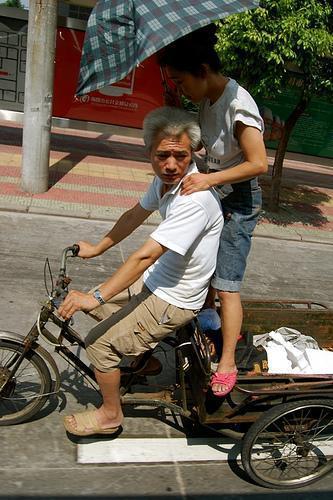How many bicycles are there?
Give a very brief answer. 1. How many people can be seen?
Give a very brief answer. 2. How many zebras are there?
Give a very brief answer. 0. 